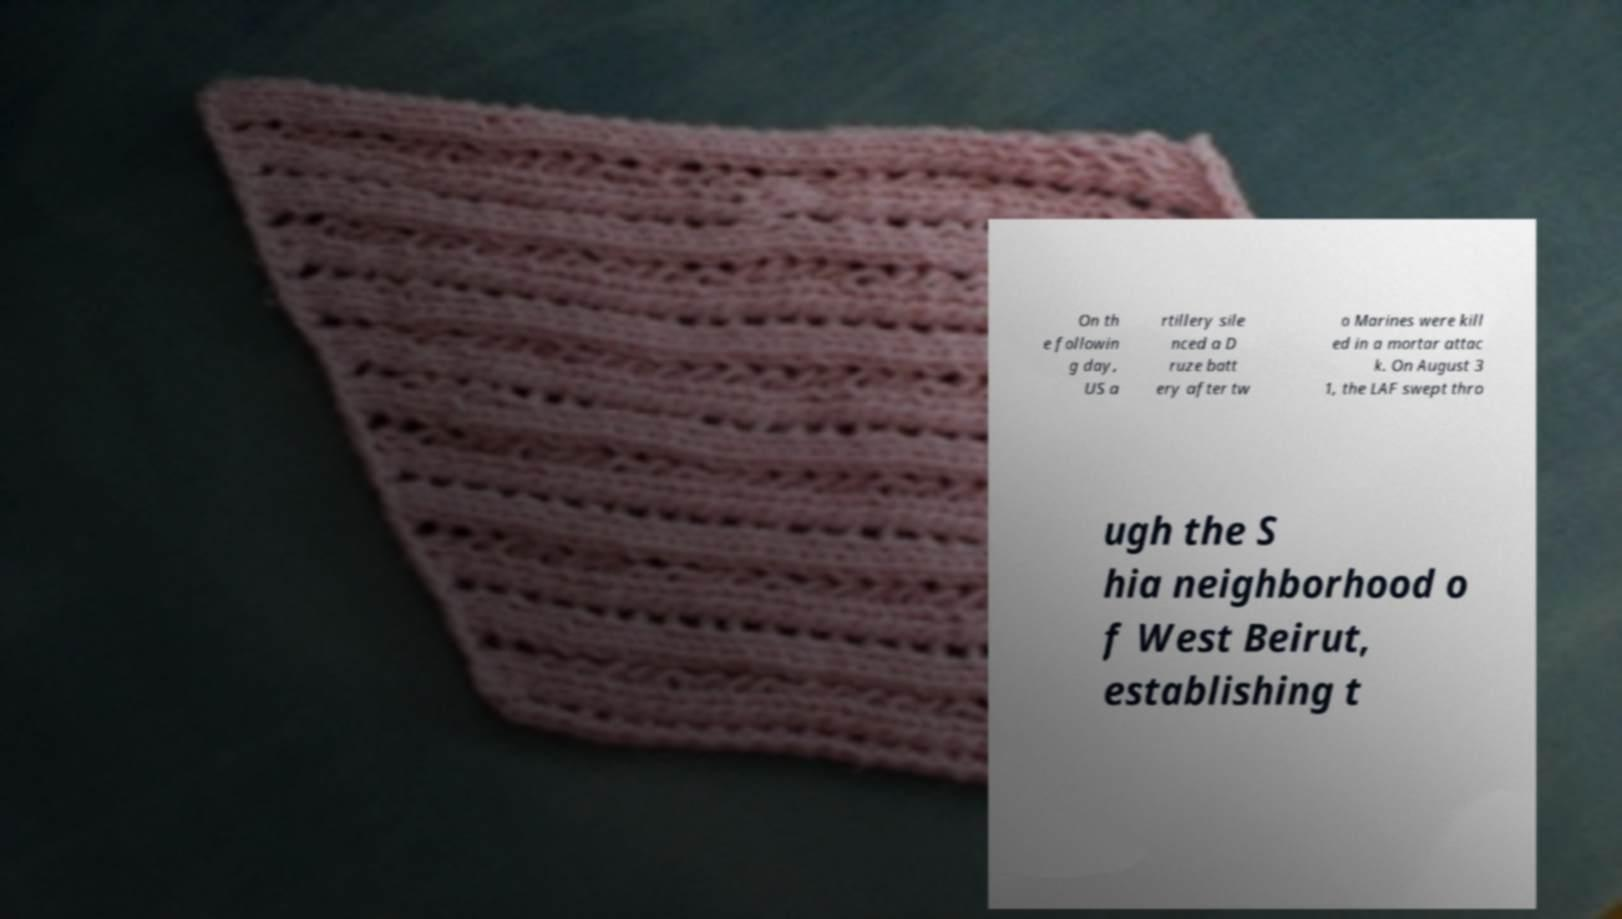Could you assist in decoding the text presented in this image and type it out clearly? On th e followin g day, US a rtillery sile nced a D ruze batt ery after tw o Marines were kill ed in a mortar attac k. On August 3 1, the LAF swept thro ugh the S hia neighborhood o f West Beirut, establishing t 